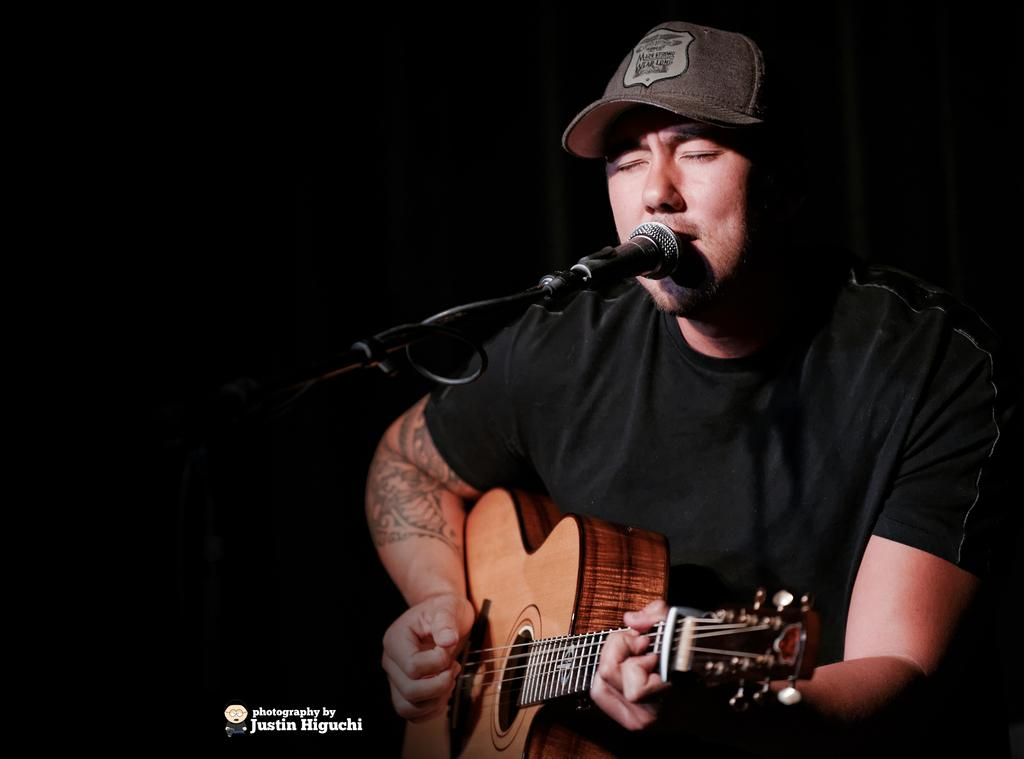What is the man in the image doing? The man is playing a guitar. What is the man wearing on his upper body? The man is wearing a black t-shirt. What is the man's position in the image? The man is sitting. What object is in front of the man? There is a microphone in front of the man. What accessory is the man wearing on his head? The man is wearing a cap on his head. What type of mark can be seen on the man's face in the image? There is no mark visible on the man's face in the image. What list is the man holding in the image? There is no list present in the image. 